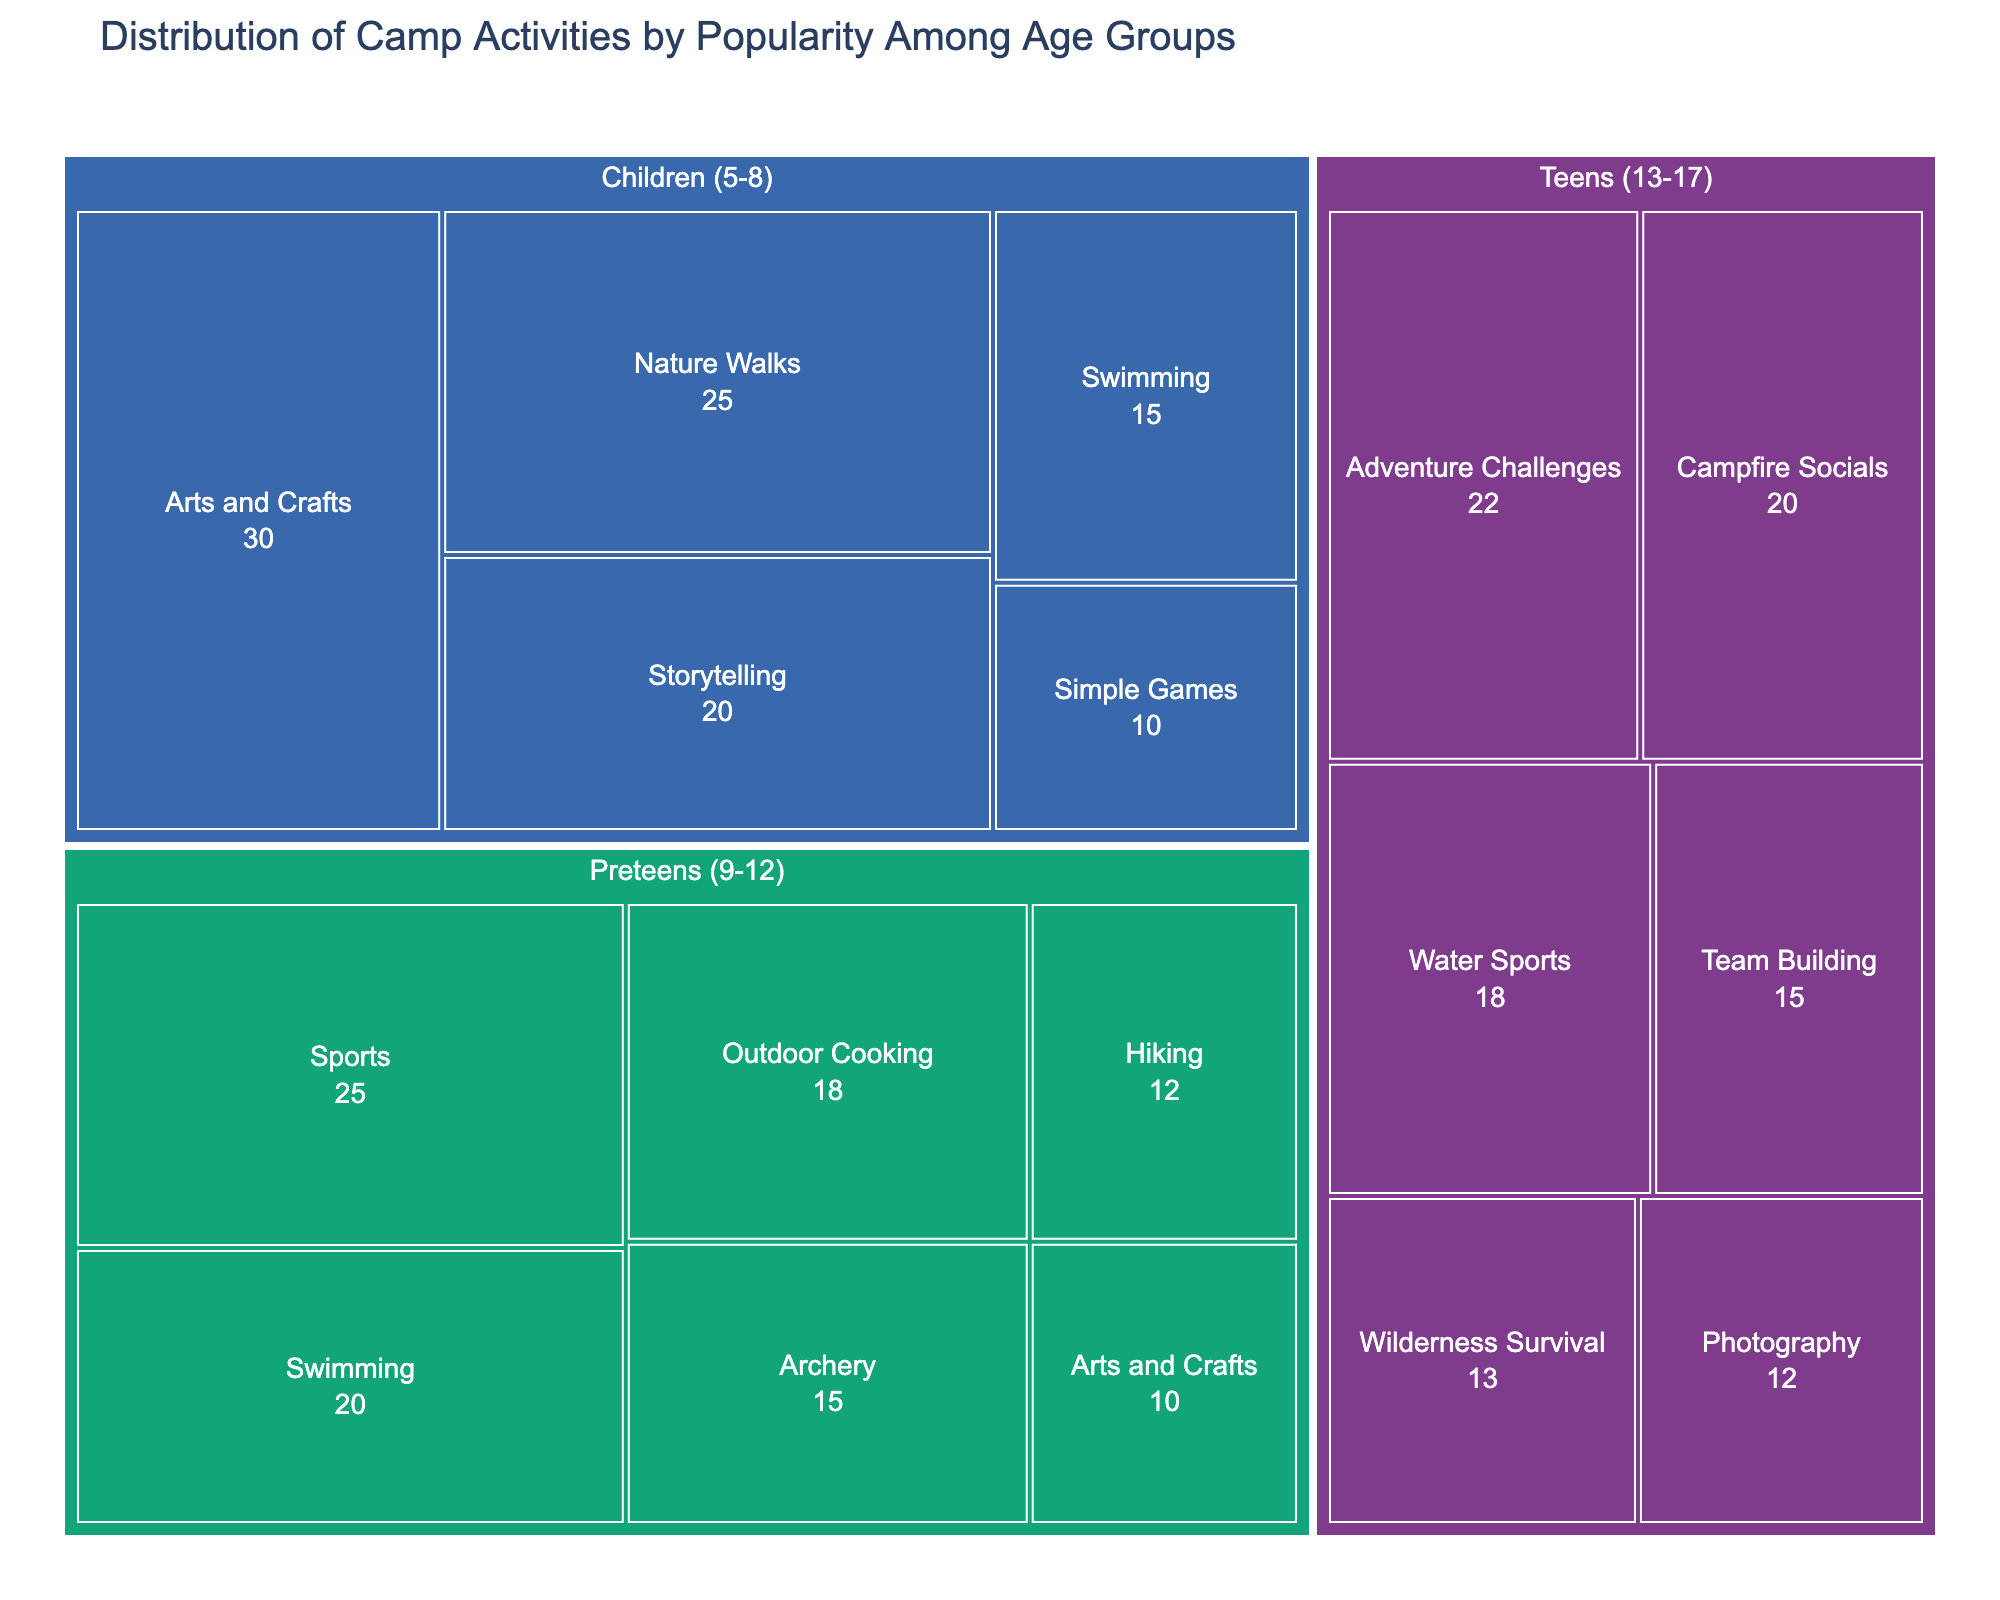What age group has the highest popularity for Arts and Crafts? By looking at the treemap, we can identify the rectangles corresponding to the "Arts and Crafts" activity and compare their sizes across the age groups. The largest rectangle represents the age group with the highest popularity for this activity.
Answer: Children (5-8) Which activity has the lowest popularity among Preteens (9-12)? Locate the section of the treemap for "Preteens (9-12)" and identify which activity within this section has the smallest rectangle. This represents the activity with the lowest popularity.
Answer: Arts and Crafts Which age group has the largest variety of activities? Count the number of different activities (rectangles) within each age group section of the treemap. The age group with the highest count has the largest variety of activities.
Answer: Teens (13-17) How many activities are more popular than Swimming in the Children (5-8) age group? Find the Swimming activity rectangle under "Children (5-8)" and count the number of activities with larger rectangles representing higher popularity values in the same age group.
Answer: Three Which activity is more popular among Teens (13-17), Water Sports or Team Building? In the "Teens (13-17)" section of the treemap, compare the sizes of the rectangles for "Water Sports" and "Team Building" to determine which is larger and thus more popular.
Answer: Water Sports How does the popularity of Simple Games for Children (5-8) compare to Outdoor Cooking for Preteens (9-12)? Compare the size of the rectangle for "Simple Games" under "Children (5-8)" to the size of the rectangle for "Outdoor Cooking" under "Preteens (9-12)".
Answer: Less popular What is the combined popularity percentage of Swimming across all age groups? Identify all the Swimming activity rectangles for each age group, sum their popularity values (15% from Children (5-8) and 20% from Preteens (9-12)), and add them together.
Answer: 35% Which age group shows a preference for Storytelling, and what is its popularity? Locate the rectangle for "Storytelling" in the treemap and identify the corresponding age group and popularity percentage associated with it.
Answer: Children (5-8), 20% What activity is equally popular among Preteens (9-12) and Teens (13-17)? Look for activities that have rectangles with equal sizes (representing the same popularity value) under the age groups "Preteens (9-12)" and "Teens (13-17)".
Answer: No activity is equally popular 